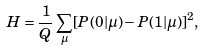Convert formula to latex. <formula><loc_0><loc_0><loc_500><loc_500>H = \frac { 1 } { Q } \sum _ { \mu } [ P ( 0 | \mu ) - P ( 1 | \mu ) ] ^ { 2 } ,</formula> 